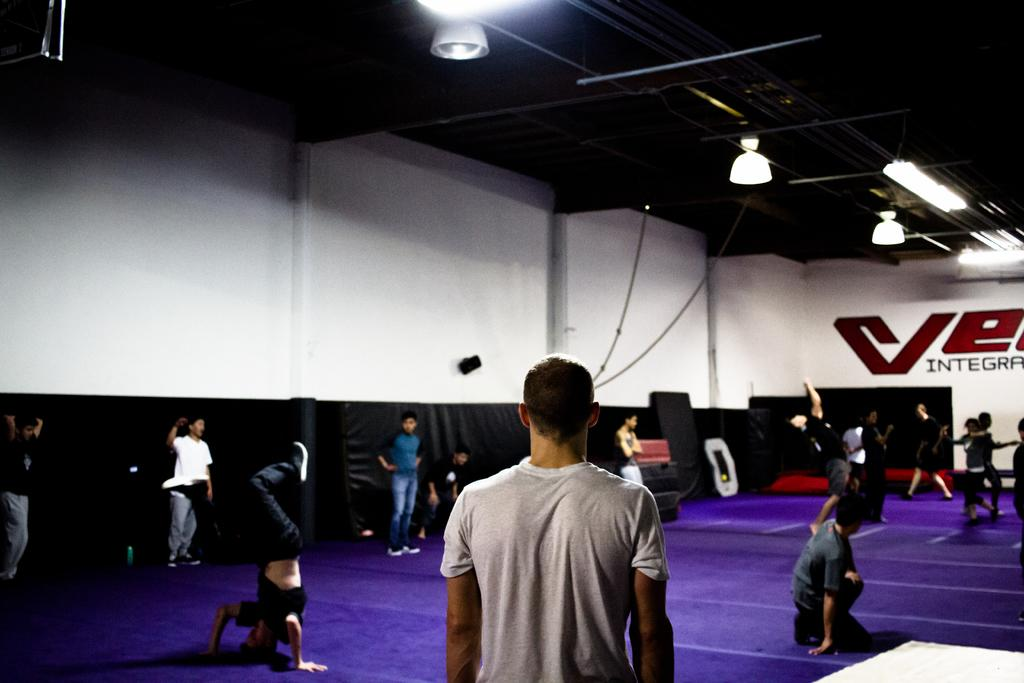How many people are in the image? There is a group of people in the image, but the exact number is not specified. What is in front of the group of people? There are beds in front of the group of people. What type of material is used for the rods in the image? The rods in the image are made of metal. What is attached to the top of the metal rods? There are lights on top of the metal rods. Can you see a net being used by the carpenter in the image? There is no carpenter or net present in the image. What phase is the moon in during the scene depicted in the image? The image does not show the moon, so it is not possible to determine its phase. 